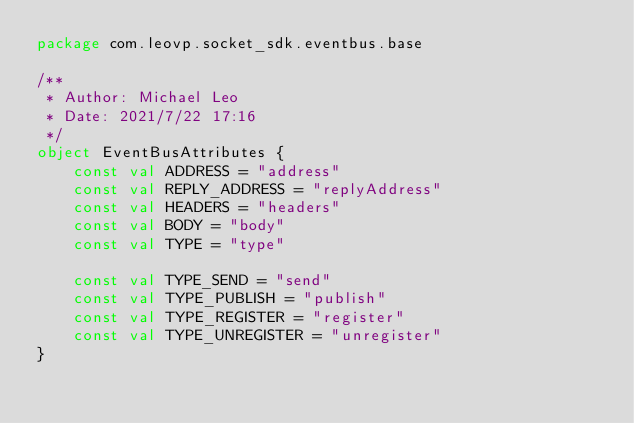<code> <loc_0><loc_0><loc_500><loc_500><_Kotlin_>package com.leovp.socket_sdk.eventbus.base

/**
 * Author: Michael Leo
 * Date: 2021/7/22 17:16
 */
object EventBusAttributes {
    const val ADDRESS = "address"
    const val REPLY_ADDRESS = "replyAddress"
    const val HEADERS = "headers"
    const val BODY = "body"
    const val TYPE = "type"

    const val TYPE_SEND = "send"
    const val TYPE_PUBLISH = "publish"
    const val TYPE_REGISTER = "register"
    const val TYPE_UNREGISTER = "unregister"
}</code> 